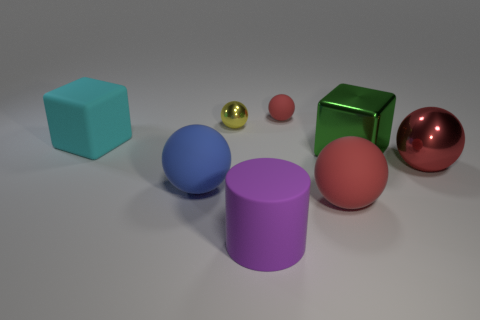Which object appears to be the heaviest? The object that appears to be the heaviest is the green cube due to its size and the material it seems to be made from, which looks like a polished metal. 